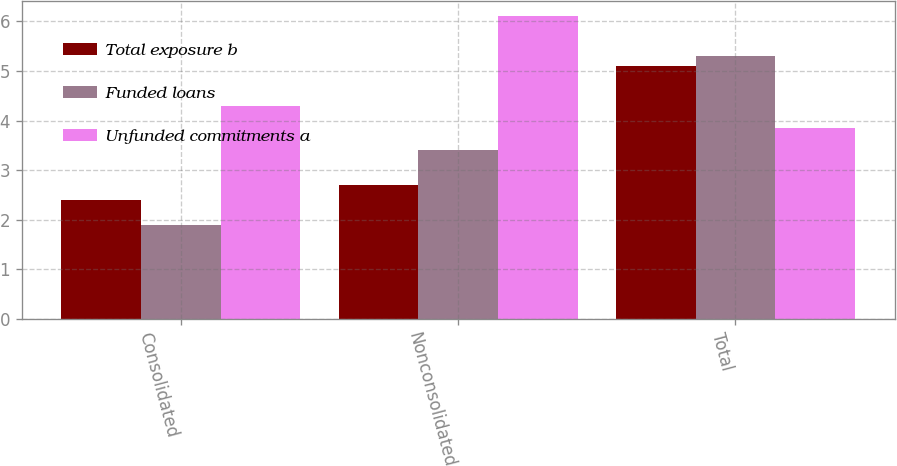Convert chart. <chart><loc_0><loc_0><loc_500><loc_500><stacked_bar_chart><ecel><fcel>Consolidated<fcel>Nonconsolidated<fcel>Total<nl><fcel>Total exposure b<fcel>2.4<fcel>2.7<fcel>5.1<nl><fcel>Funded loans<fcel>1.9<fcel>3.4<fcel>5.3<nl><fcel>Unfunded commitments a<fcel>4.3<fcel>6.1<fcel>3.85<nl></chart> 